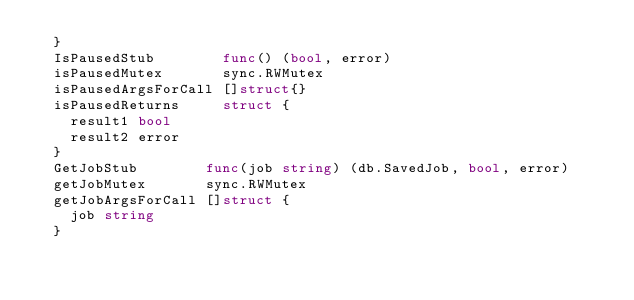<code> <loc_0><loc_0><loc_500><loc_500><_Go_>	}
	IsPausedStub        func() (bool, error)
	isPausedMutex       sync.RWMutex
	isPausedArgsForCall []struct{}
	isPausedReturns     struct {
		result1 bool
		result2 error
	}
	GetJobStub        func(job string) (db.SavedJob, bool, error)
	getJobMutex       sync.RWMutex
	getJobArgsForCall []struct {
		job string
	}</code> 